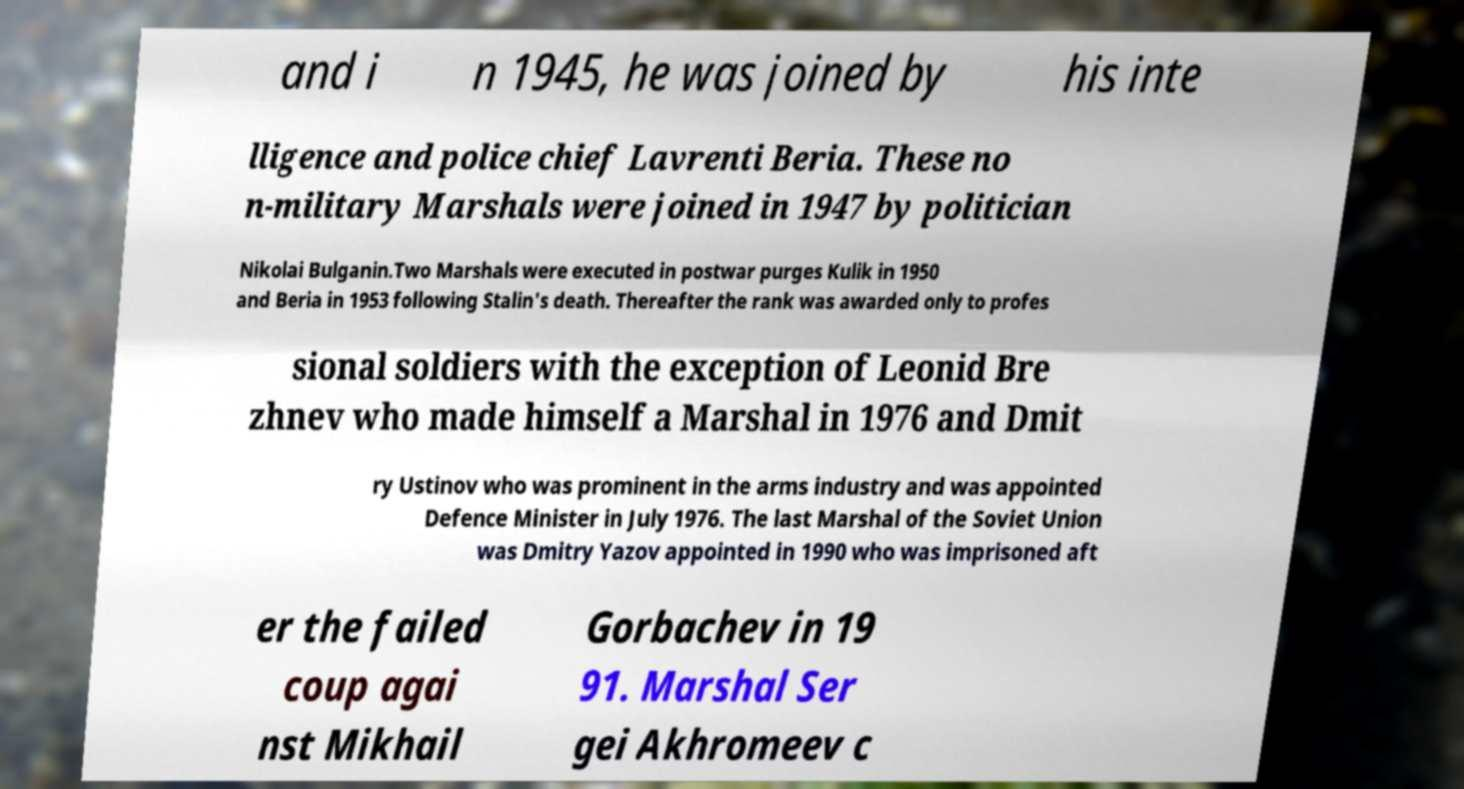What messages or text are displayed in this image? I need them in a readable, typed format. and i n 1945, he was joined by his inte lligence and police chief Lavrenti Beria. These no n-military Marshals were joined in 1947 by politician Nikolai Bulganin.Two Marshals were executed in postwar purges Kulik in 1950 and Beria in 1953 following Stalin's death. Thereafter the rank was awarded only to profes sional soldiers with the exception of Leonid Bre zhnev who made himself a Marshal in 1976 and Dmit ry Ustinov who was prominent in the arms industry and was appointed Defence Minister in July 1976. The last Marshal of the Soviet Union was Dmitry Yazov appointed in 1990 who was imprisoned aft er the failed coup agai nst Mikhail Gorbachev in 19 91. Marshal Ser gei Akhromeev c 